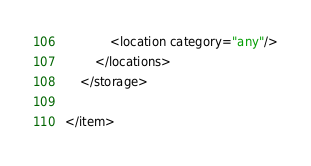<code> <loc_0><loc_0><loc_500><loc_500><_XML_>			<location category="any"/>
		</locations>
	</storage>

</item></code> 